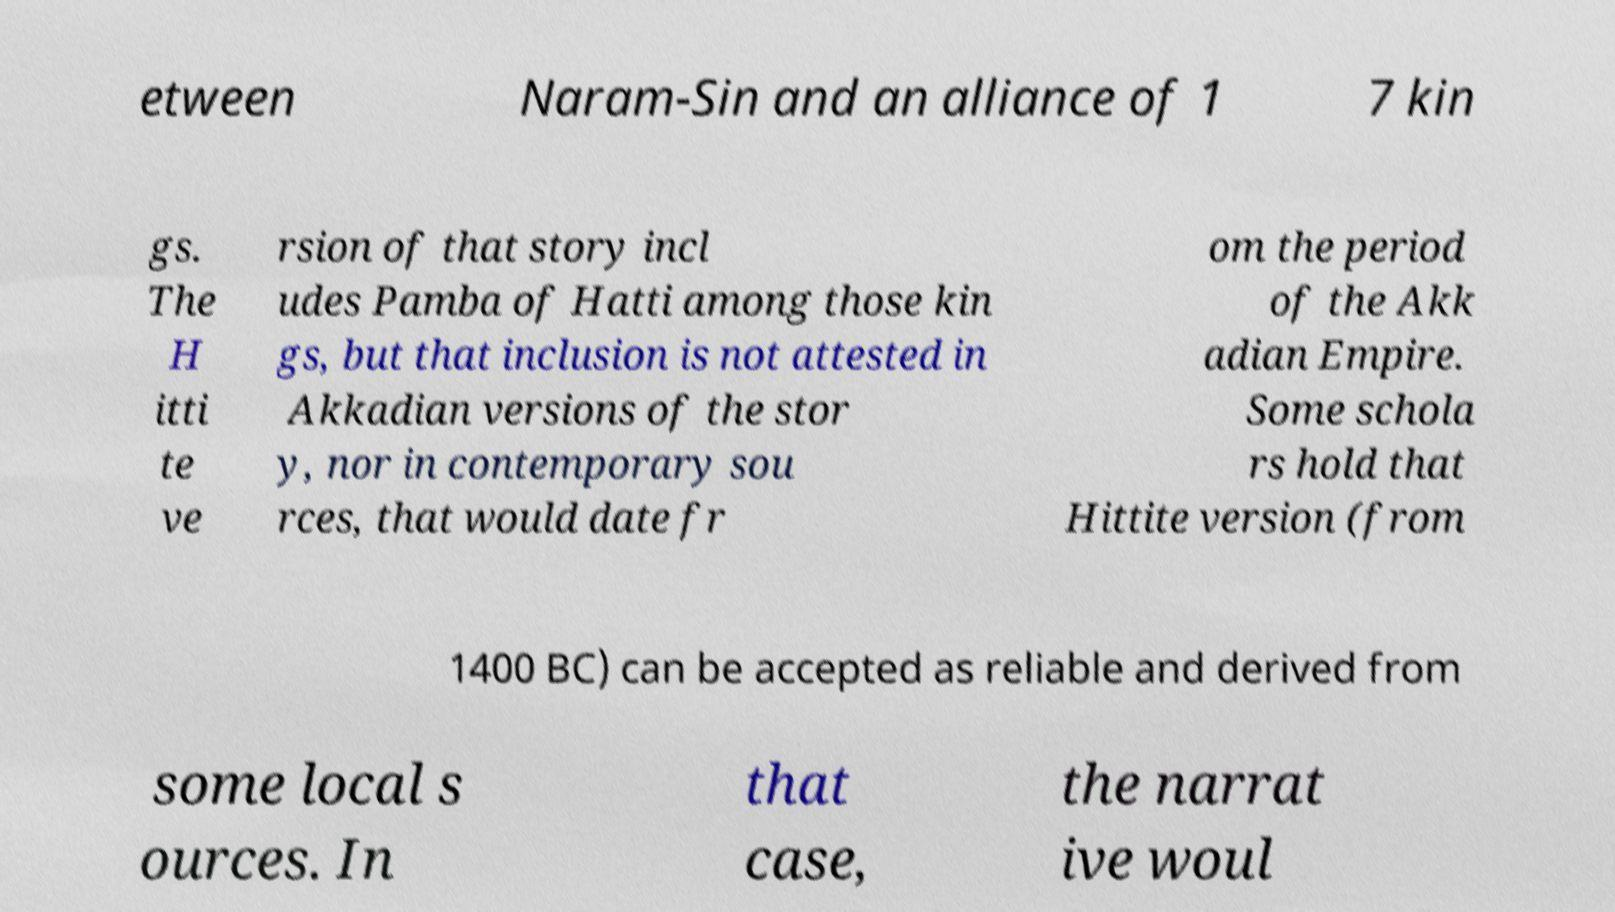For documentation purposes, I need the text within this image transcribed. Could you provide that? etween Naram-Sin and an alliance of 1 7 kin gs. The H itti te ve rsion of that story incl udes Pamba of Hatti among those kin gs, but that inclusion is not attested in Akkadian versions of the stor y, nor in contemporary sou rces, that would date fr om the period of the Akk adian Empire. Some schola rs hold that Hittite version (from 1400 BC) can be accepted as reliable and derived from some local s ources. In that case, the narrat ive woul 